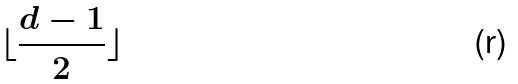<formula> <loc_0><loc_0><loc_500><loc_500>\lfloor \frac { d - 1 } { 2 } \rfloor</formula> 